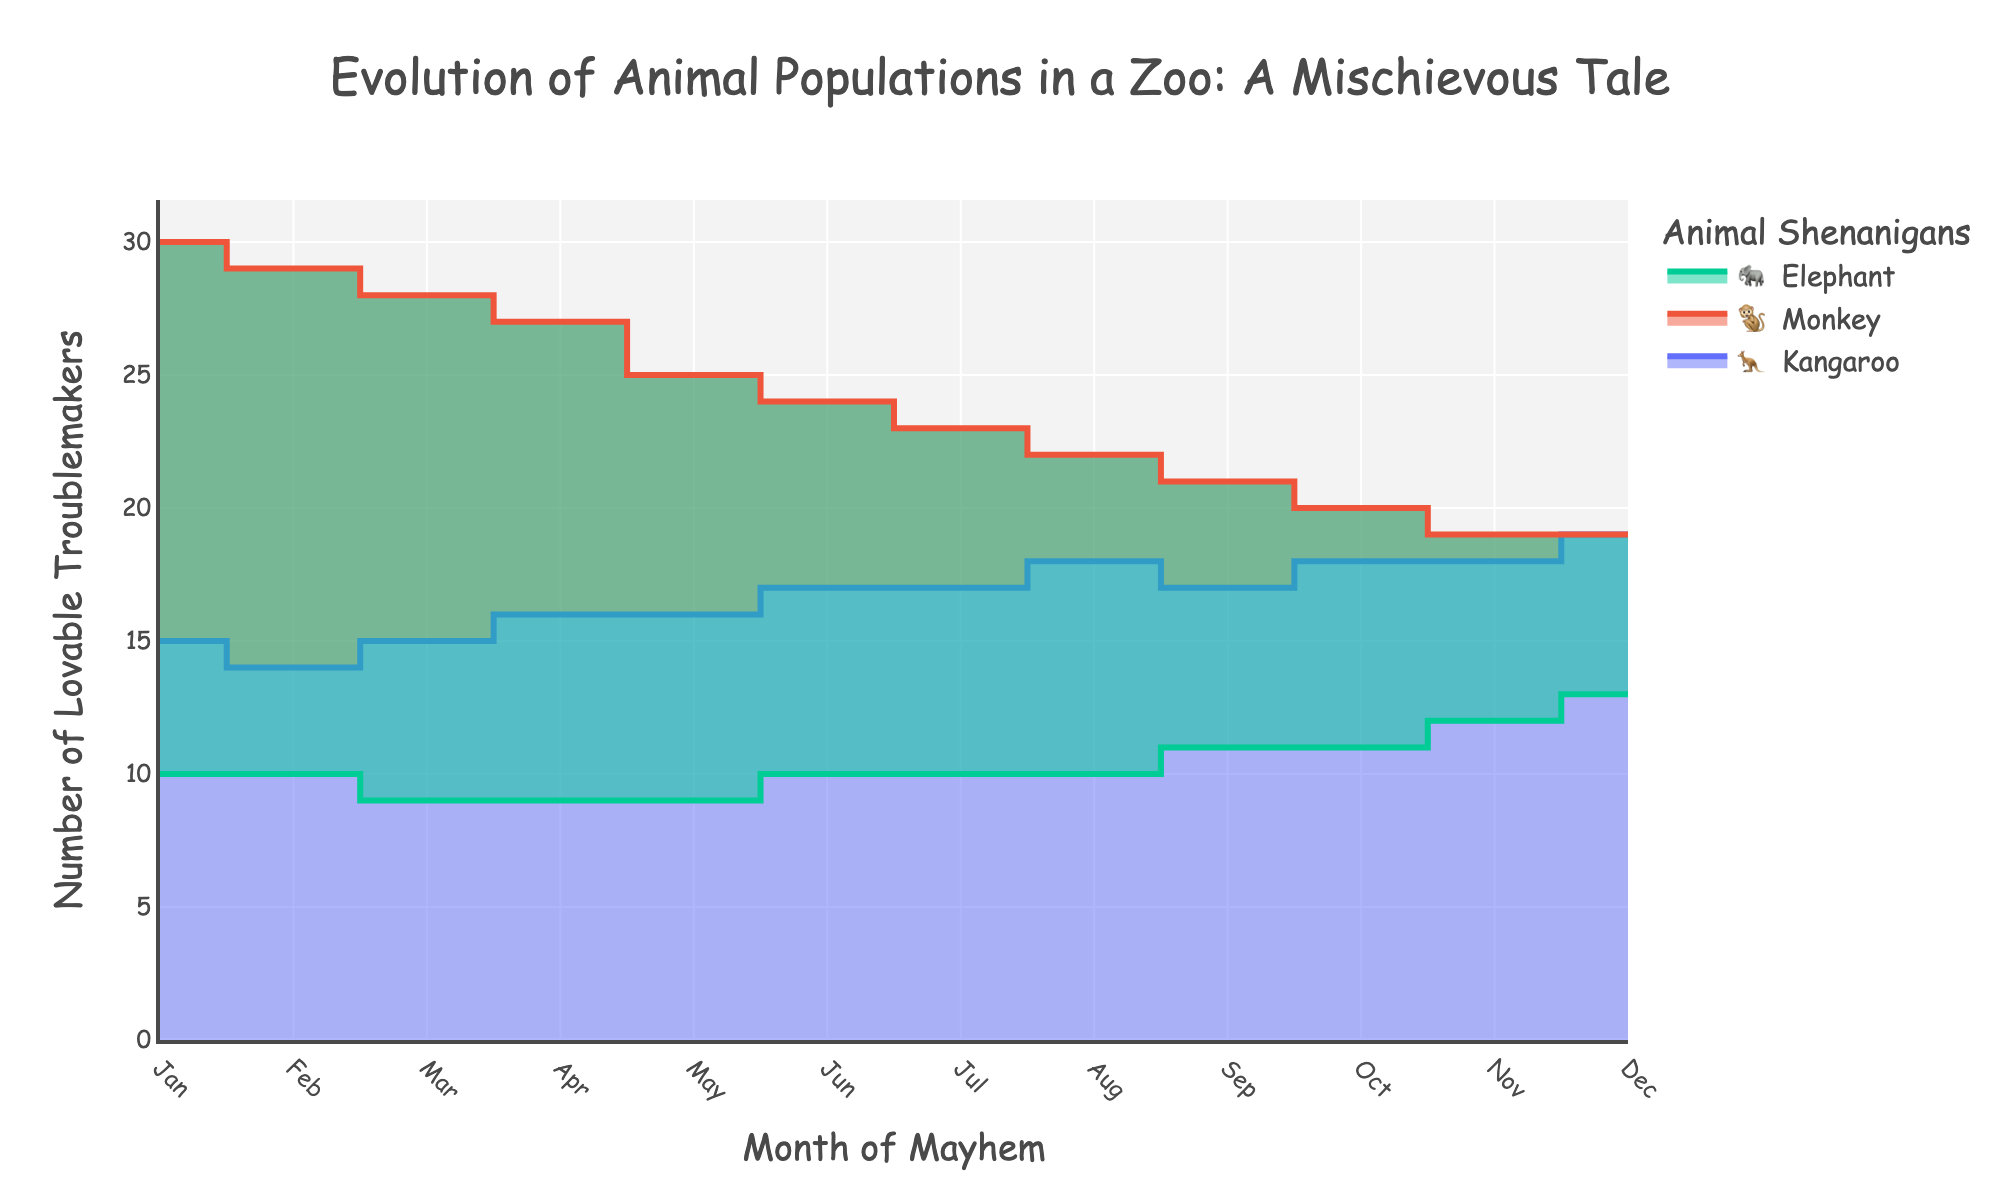Which animal's population grows the most from January to December? To find the animal with the largest population growth, look at the starting and ending points of each animal's curve. Kangaroos go from 15 to 19, Monkeys from 30 to 19, and Elephants from 10 to 13. The Kangaroo's population increases by 19 - 15 = 4, Monkeys decrease by 19 - 30 = -11, and Elephants increase by 13 - 10 = 3. Thus, Kangaroos grow the most.
Answer: Kangaroo Which month witnessed the highest number of mischievous incidents for Monkeys? Look at the highest peak in the mischievous behavior data for Monkeys over the months. The highest value (13 incidents) is recorded in June.
Answer: June By how much does the Elephant population change between the months of March and September? Check the population of Elephants in March (9) and September (11). The change is calculated as 11 - 9 = 2.
Answer: 2 What is the trend of the Monkey population across the year? Observe the curve for Monkeys: It starts high in January, decreases gradually month by month, and stabilizes in December.
Answer: Decreasing Compare the total mischievous incidents by Kangaroos in the first half of the year (January to June) to the second half (July to December). Sum the incidents from Jan to June (3 + 2 + 4 + 5 + 3 + 4 = 21) and from July to Dec (3 + 2 + 3 + 4 + 3 + 4 = 19). The first half has 21 incidents, while the second half has 19.
Answer: First half is greater What is the average population of the Elephants across all months? To find the average, sum the populations of elephants for all months and divide by 12. (10 + 10 + 9 + 9 + 9 + 10 + 10 + 10 + 11 + 11 + 12 + 13) / 12 = 11.
Answer: 10 During which month did Monkeys and Kangaroos have the same population? Locate the point where the population curves for Monkeys and Kangaroos intersect. This happens in December where both populations are 19.
Answer: December Which animal had the least variation in population throughout the year? Analyze the fluctuations in the curves. The Elephant population fluctuates between 9 to 13, Monkeys from 30 to 19, and Kangaroos from 14 to 19. Therefore, the Elephant's population has the least fluctuation.
Answer: Elephant 